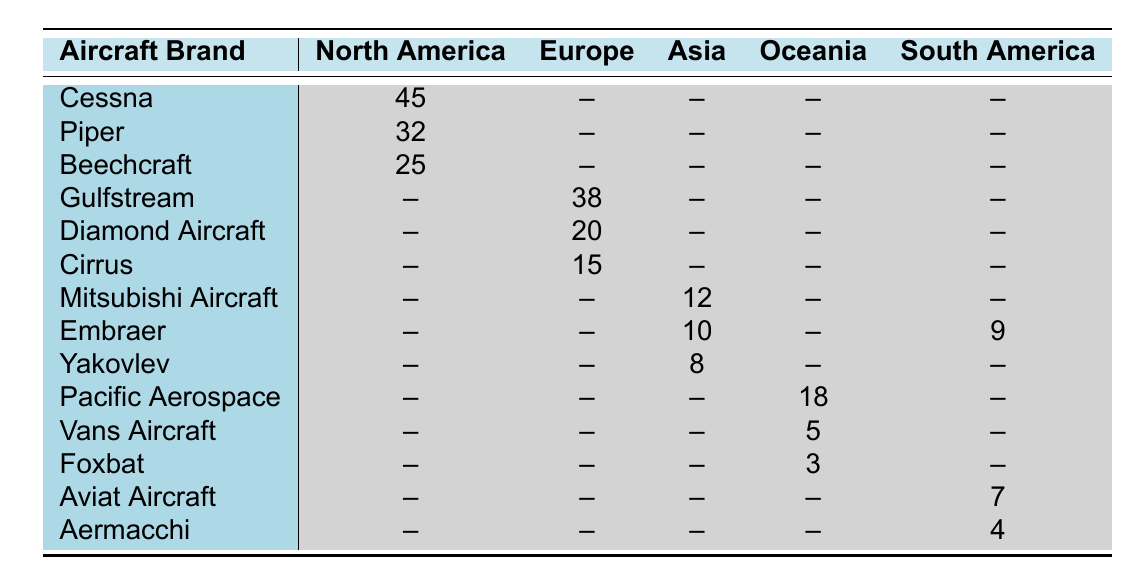What is the sketch count for Cessna in North America? The table shows that the sketch count for Cessna in North America is listed under the North America column next to the Cessna row, which states 45.
Answer: 45 Which aircraft brand has the highest sketch count in Europe? By examining the Europe column, Gulfstream has the highest sketch count at 38, which is greater than the other brands listed in the same region.
Answer: Gulfstream Are there any aircraft brands sketched in Asia that also appear in South America? The table lists Embraer which is marked for both Asia with a sketch count of 10 and South America with a sketch count of 9, confirming that Embraer is present in both regions.
Answer: Yes What is the total sketch count of all aircraft brands in Oceania? Summing the sketch counts for Oceania: Pacific Aerospace (18) + Vans Aircraft (5) + Foxbat (3) gives a total of 26. Therefore, the total sketch count for Oceania is 18 + 5 + 3 = 26.
Answer: 26 Is the sketch count for Diamond Aircraft more than the combined sketch counts of Vans Aircraft and Foxbat? First, we find the sketch count for Diamond Aircraft in Europe, which is 20. Then, we sum the sketch counts for Vans Aircraft (5) and Foxbat (3) to get 8. Comparing 20 (Diamond Aircraft) with 8 (Vans and Foxbat combined), we conclude that yes, it is more.
Answer: Yes Which region has the lowest total sketch counts for aircraft brands? To find the lowest total sketch counts, we add the sketch counts for each region: North America (102), Europe (73), Asia (30), Oceania (26), and South America (20). South America has the lowest with a total of 20.
Answer: South America How many aircraft brands were sketched more than 15 times in North America? In North America, Cessna (45), Piper (32), and Beechcraft (25) are all sketched more than 15 times. Counting these gives a total of 3 aircraft brands.
Answer: 3 What is the average sketch count for aircraft brands in Europe? The average can be calculated using the sketch counts for Europe: Gulfstream (38), Diamond Aircraft (20), and Cirrus (15). The total is 73, and since there are 3 brands, the average is 73/3 = 24.33.
Answer: 24.33 What percentage of the total sketches in the table were made for Cessna? First, we add all sketch counts: 45+32+25+38+20+15+12+10+8+18+5+3+7+4+9 =  344. The sketch count for Cessna is 45. The percentage is (45/344) * 100 ≈ 13.09%.
Answer: 13.09% 